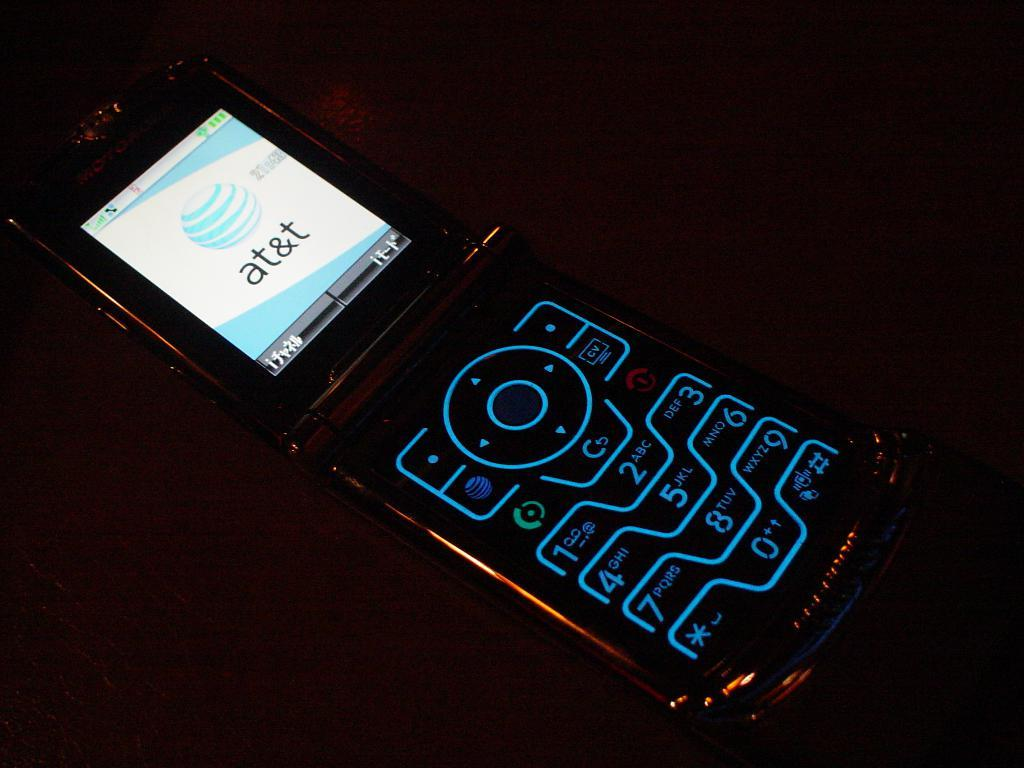<image>
Summarize the visual content of the image. An AT&T phone is turned on and displays the company logo on the screen. 